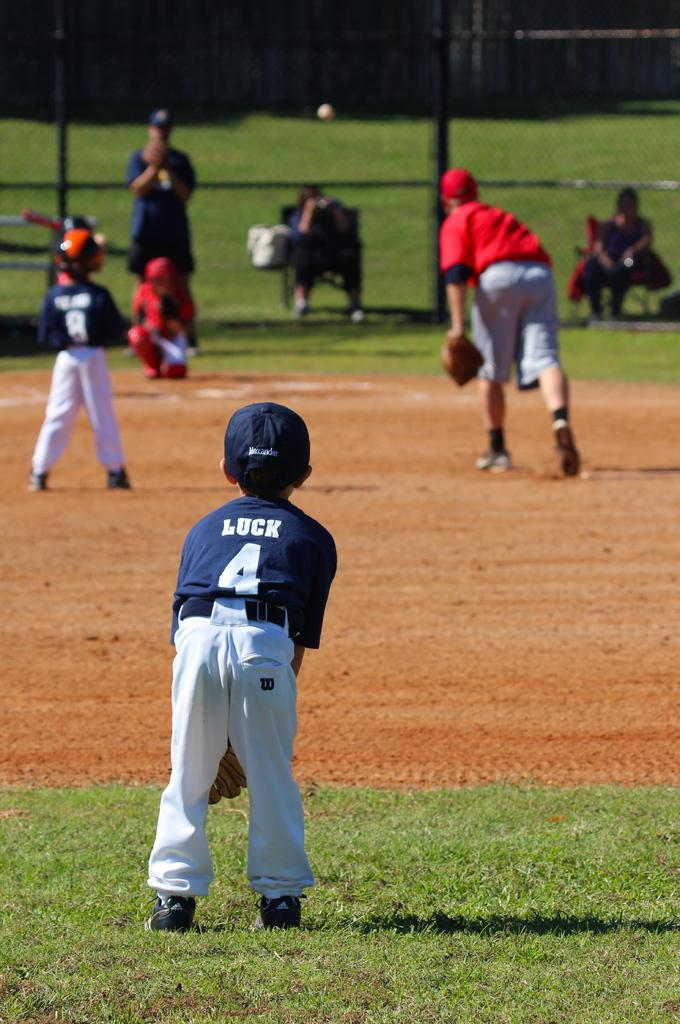<image>
Summarize the visual content of the image. A player with Luck and number 4 on his jersey waits for the play to begin. 